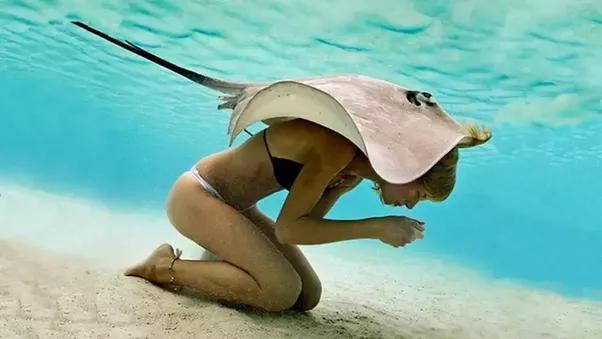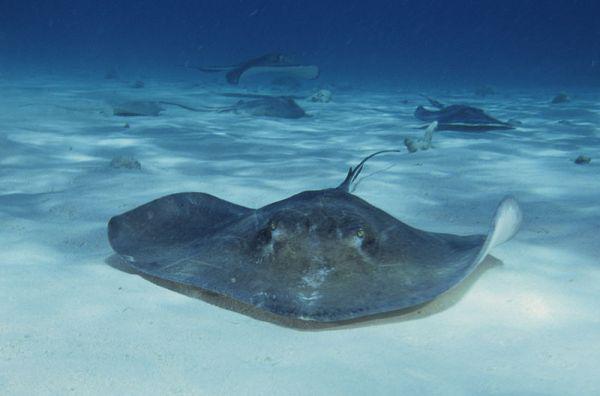The first image is the image on the left, the second image is the image on the right. Evaluate the accuracy of this statement regarding the images: "One image in the pair has a human.". Is it true? Answer yes or no. Yes. The first image is the image on the left, the second image is the image on the right. Examine the images to the left and right. Is the description "One image shows at least one person in the water with a stingray." accurate? Answer yes or no. Yes. 